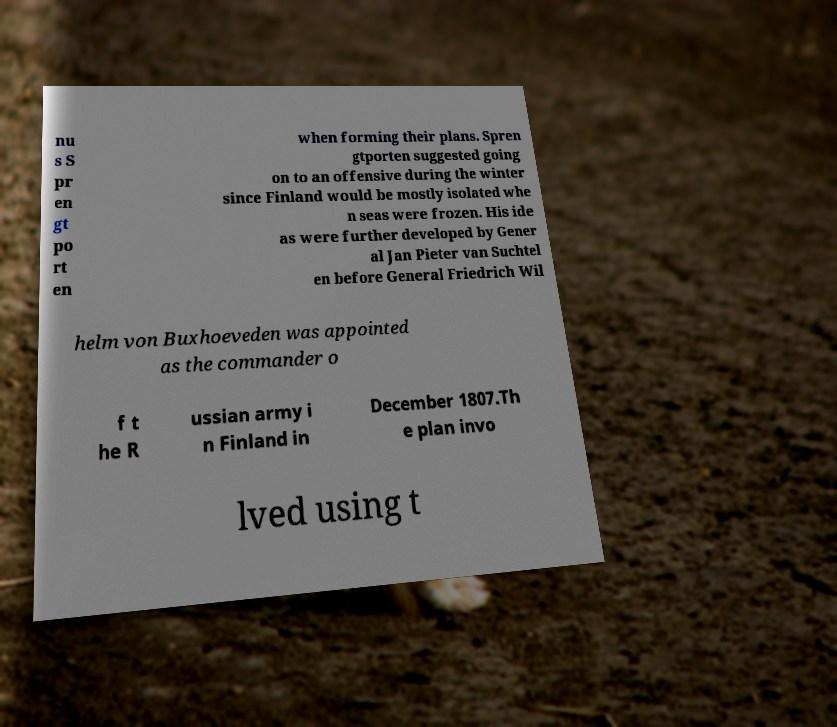For documentation purposes, I need the text within this image transcribed. Could you provide that? nu s S pr en gt po rt en when forming their plans. Spren gtporten suggested going on to an offensive during the winter since Finland would be mostly isolated whe n seas were frozen. His ide as were further developed by Gener al Jan Pieter van Suchtel en before General Friedrich Wil helm von Buxhoeveden was appointed as the commander o f t he R ussian army i n Finland in December 1807.Th e plan invo lved using t 